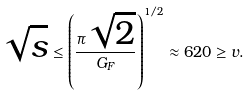<formula> <loc_0><loc_0><loc_500><loc_500>\sqrt { s } \leq \left ( \frac { \pi \sqrt { 2 } } { G _ { F } } \right ) ^ { 1 / 2 } \approx 6 2 0 \geq v .</formula> 